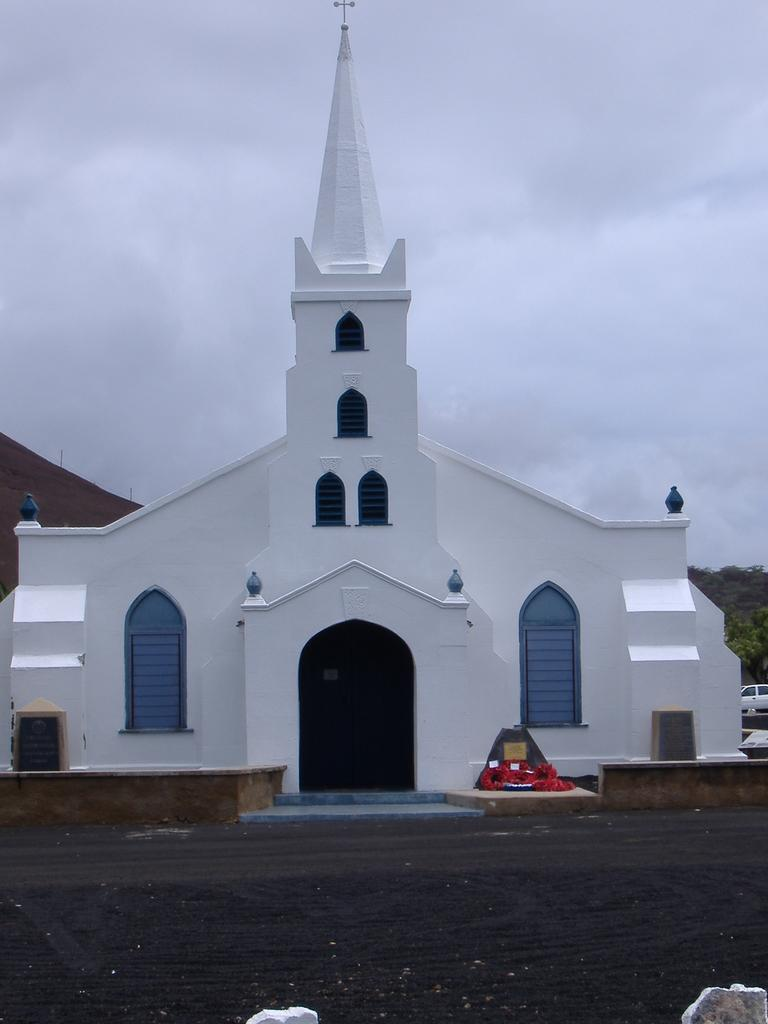What is the main subject in the center of the image? There is a church in the center of the image. What is located at the bottom of the image? There is a road at the bottom of the image. What can be seen in the background of the image? There are trees and a car in the background of the image. What type of locket is the priest wearing in the image? There is no priest or locket present in the image. Can you tell me how the car is expressing anger in the image? There is no indication of anger in the image, and the car is an inanimate object that cannot express emotions. 